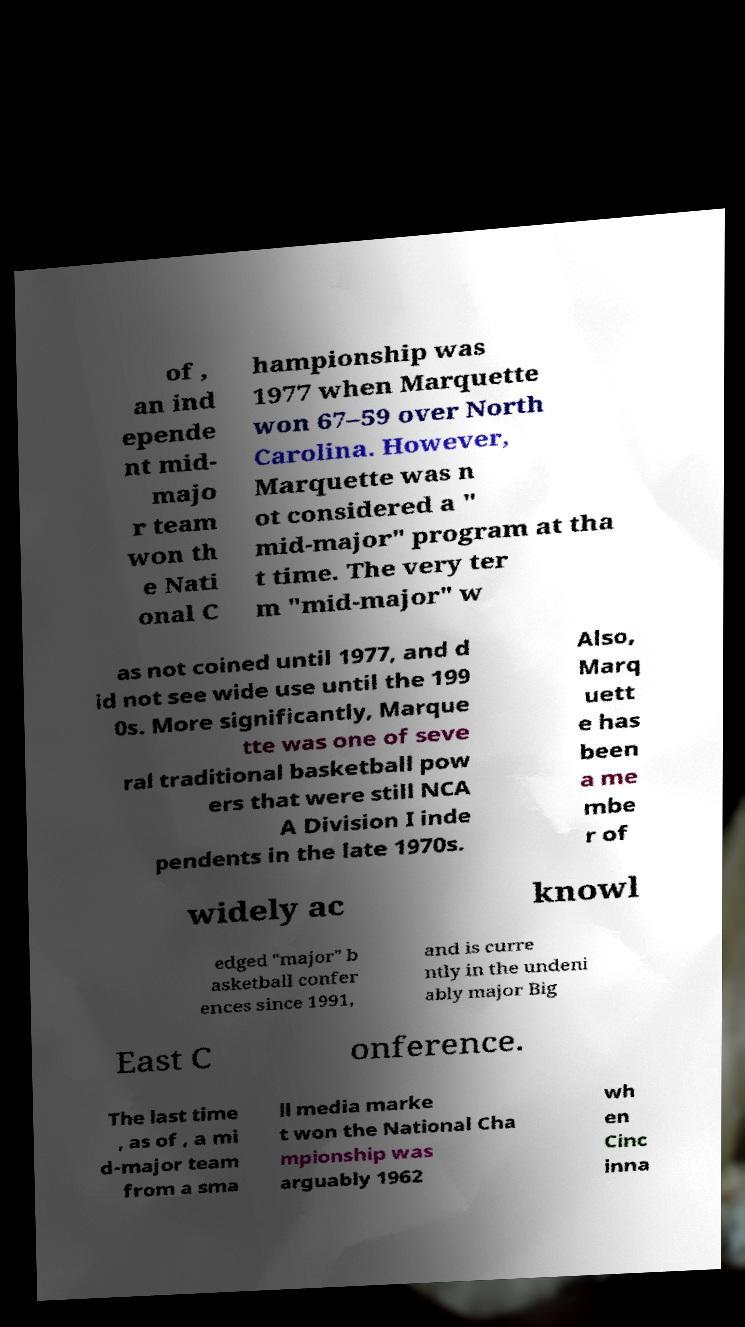What messages or text are displayed in this image? I need them in a readable, typed format. of , an ind epende nt mid- majo r team won th e Nati onal C hampionship was 1977 when Marquette won 67–59 over North Carolina. However, Marquette was n ot considered a " mid-major" program at tha t time. The very ter m "mid-major" w as not coined until 1977, and d id not see wide use until the 199 0s. More significantly, Marque tte was one of seve ral traditional basketball pow ers that were still NCA A Division I inde pendents in the late 1970s. Also, Marq uett e has been a me mbe r of widely ac knowl edged "major" b asketball confer ences since 1991, and is curre ntly in the undeni ably major Big East C onference. The last time , as of , a mi d-major team from a sma ll media marke t won the National Cha mpionship was arguably 1962 wh en Cinc inna 